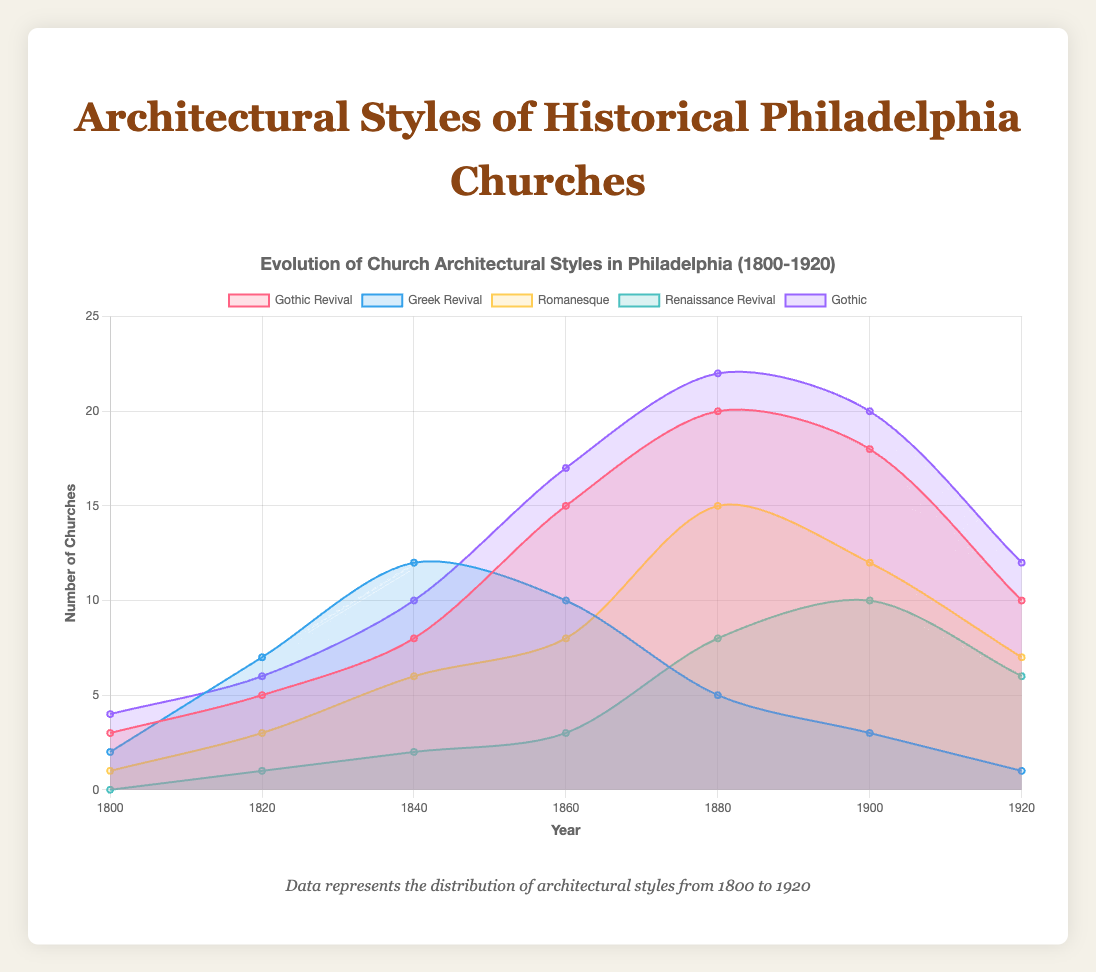What architectural style saw the highest number of churches built in 1920? To determine this, look at the year 1920 on the x-axis and compare the y-values of all architectural styles. The style with the highest y-value is Gothic, with 12 churches.
Answer: Gothic In which year was the number of Gothic Revival churches the highest? By examining the area chart and tracing the Gothic Revival line across the years, you can see that the highest point is at 1880 with 20 churches.
Answer: 1880 Which architectural style had the least number of churches built in 1840? Look at the year 1840 on the x-axis and compare the y-values of all architectural styles. The style with the lowest y-value is Renaissance Revival, with only 2 churches.
Answer: Renaissance Revival What is the total number of churches for Romanesque architecture built between 1800 and 1920? Sum the counts for Romanesque at each year: 1 (1800) + 3 (1820) + 6 (1840) + 8 (1860) + 15 (1880) + 12 (1900) + 7 (1920) = 52 churches.
Answer: 52 Which year saw the highest combined count of all architectural styles? Sum the counts for each style at each year and compare the results. The year 1880 has the highest combined count (20 + 5 + 15 + 8 + 22 = 70).
Answer: 1880 What trend is noticeable for the Gothic architectural style from 1800 to 1920? Trace the Gothic style across the years: It shows a general increase in the number of churches built until 1880, peaks, then declines towards 1920.
Answer: Increase then decline How many more Gothic churches were built than Greek Revival churches in 1860? Subtract the count of Greek Revival churches from the count of Gothic churches in 1860: 17 (Gothic) - 10 (Greek Revival) = 7 more Gothic churches.
Answer: 7 What percentage of the total churches built in 1880 were of Renaissance Revival style? First, find the total number of churches built in 1880: 20 (Gothic Revival) + 5 (Greek Revival) + 15 (Romanesque) + 8 (Renaissance Revival) + 22 (Gothic) = 70. Then, calculate the percentage: (8 / 70) * 100 ≈ 11.4%.
Answer: 11.4% Which architectural style shows the most significant decline in the number of churches built from 1900 to 1920? Compare the counts for each style in 1900 and 1920 and find the difference. Gothic Revival drops from 18 to 10 (a decline of 8 churches), which is the biggest decrease.
Answer: Gothic Revival Which two architectural styles had the same number of churches built in 1820? By examining the 1820 data points visually, Romanesque and Renaissance Revival both show 1 church built.
Answer: Romanesque and Renaissance Revival 